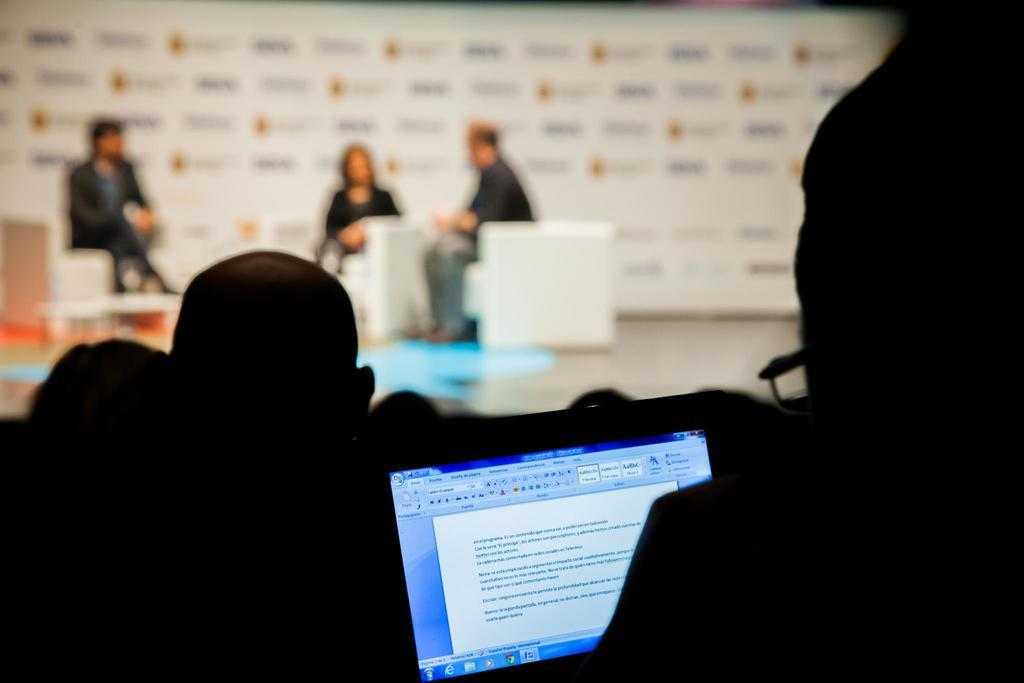What can be seen at the bottom of the image? There is a laptop screen visible at the bottom of the image. Who or what is present in the image? There are people in the image. Can you describe the background of the image? The background has a blurred view. How many people are sitting on chairs in the image? There are three persons sitting on chairs in the image. What type of string is being used to control the mass of the people in the image? There is no string or mass control present in the image; it features a laptop screen and people sitting on chairs. 